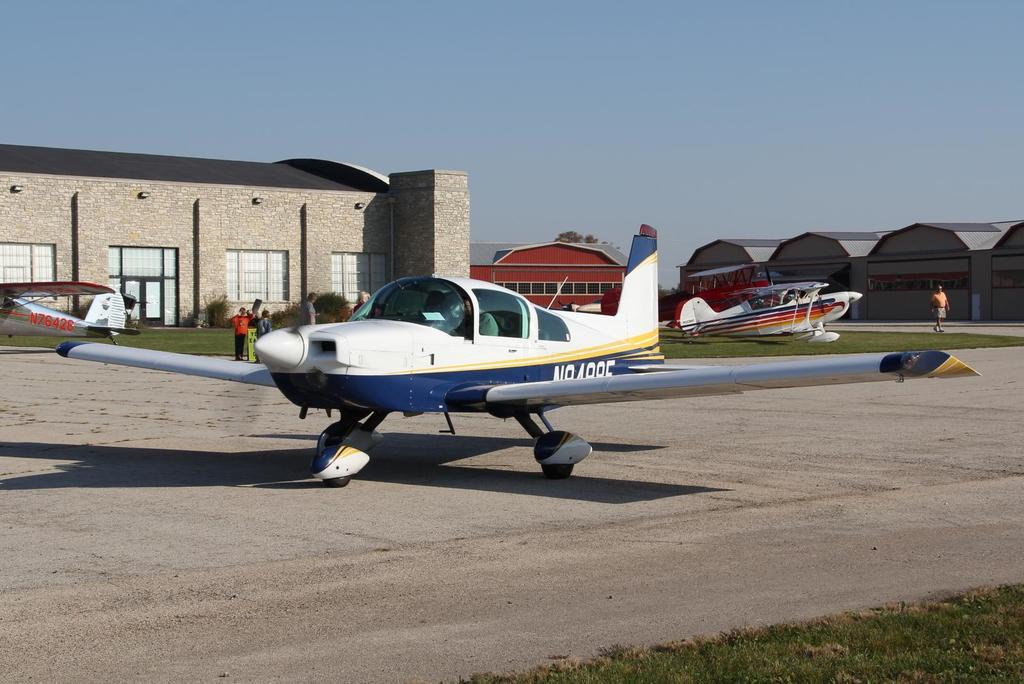<image>
Offer a succinct explanation of the picture presented. several small private planes are sitting around this yard, including one with the tag N76426 